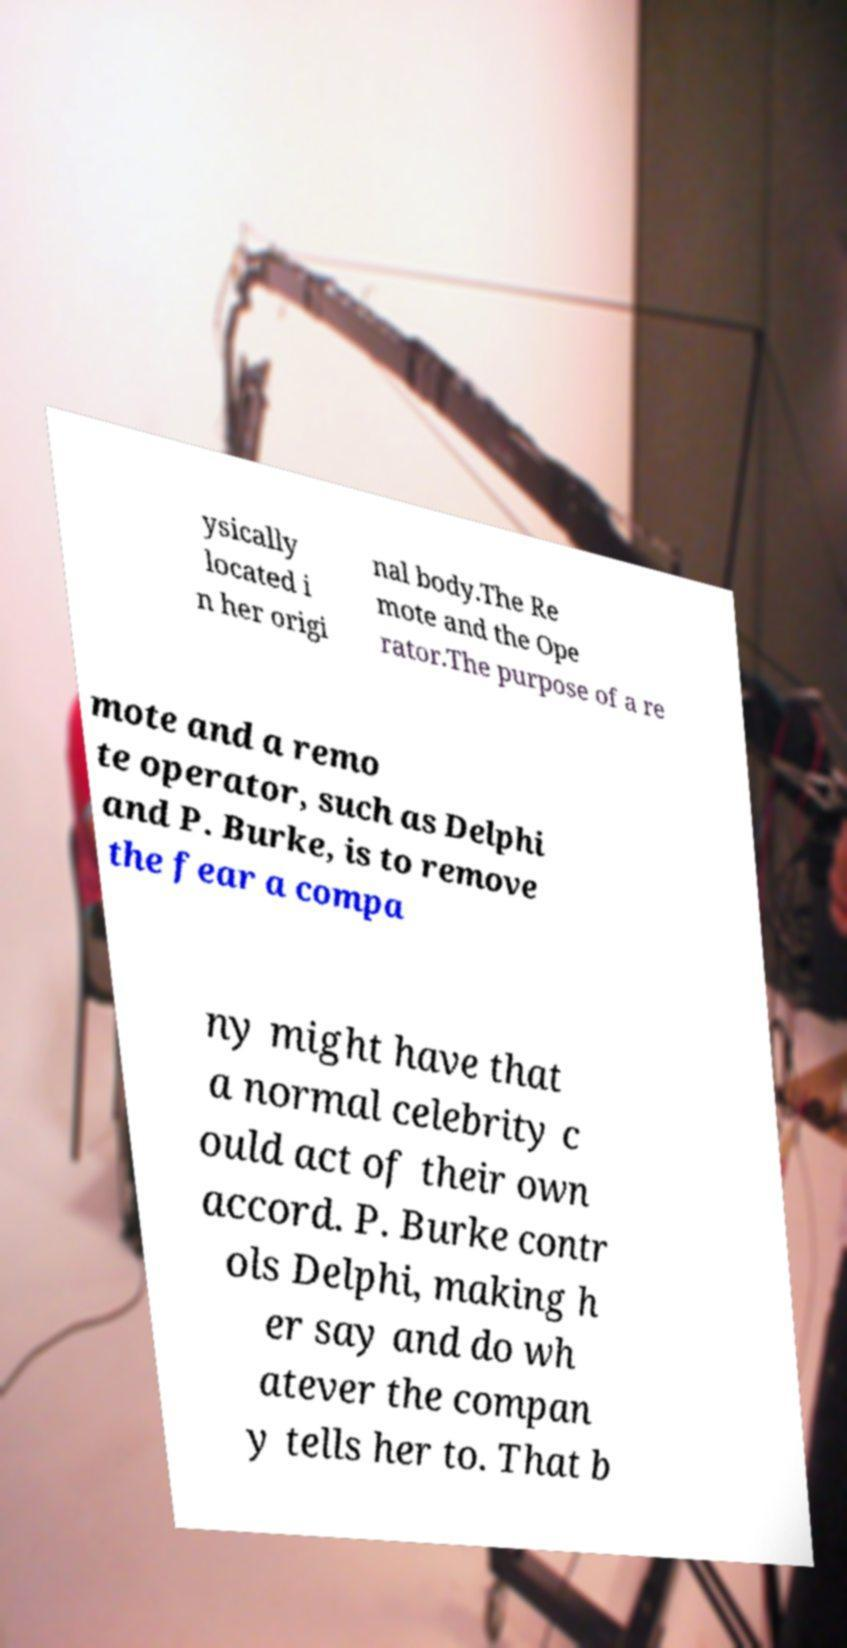I need the written content from this picture converted into text. Can you do that? ysically located i n her origi nal body.The Re mote and the Ope rator.The purpose of a re mote and a remo te operator, such as Delphi and P. Burke, is to remove the fear a compa ny might have that a normal celebrity c ould act of their own accord. P. Burke contr ols Delphi, making h er say and do wh atever the compan y tells her to. That b 